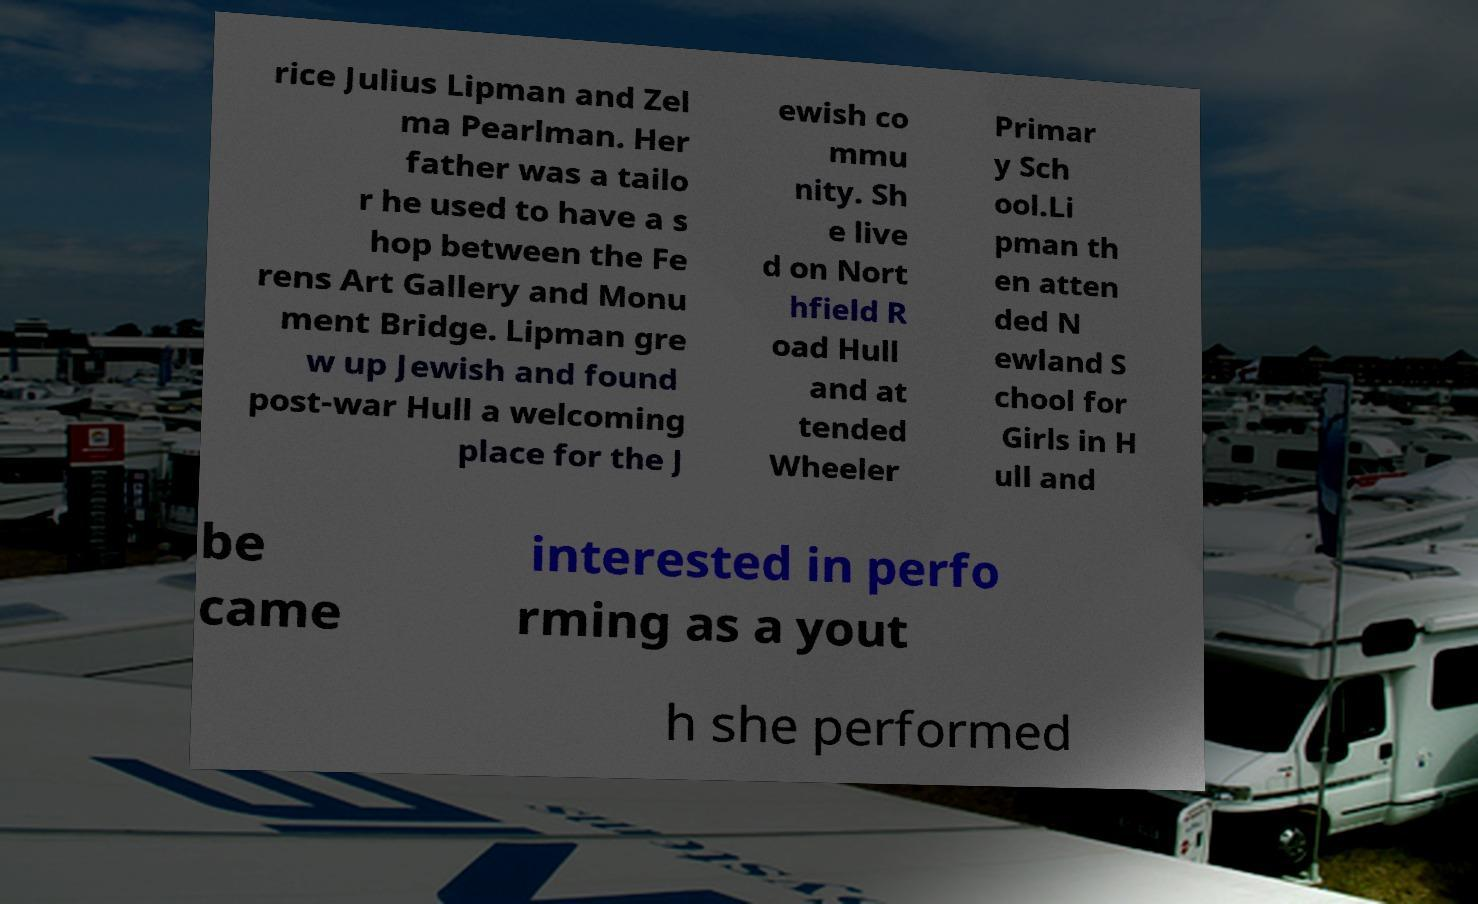Please read and relay the text visible in this image. What does it say? rice Julius Lipman and Zel ma Pearlman. Her father was a tailo r he used to have a s hop between the Fe rens Art Gallery and Monu ment Bridge. Lipman gre w up Jewish and found post-war Hull a welcoming place for the J ewish co mmu nity. Sh e live d on Nort hfield R oad Hull and at tended Wheeler Primar y Sch ool.Li pman th en atten ded N ewland S chool for Girls in H ull and be came interested in perfo rming as a yout h she performed 